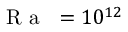Convert formula to latex. <formula><loc_0><loc_0><loc_500><loc_500>{ R a } = 1 0 ^ { 1 2 }</formula> 